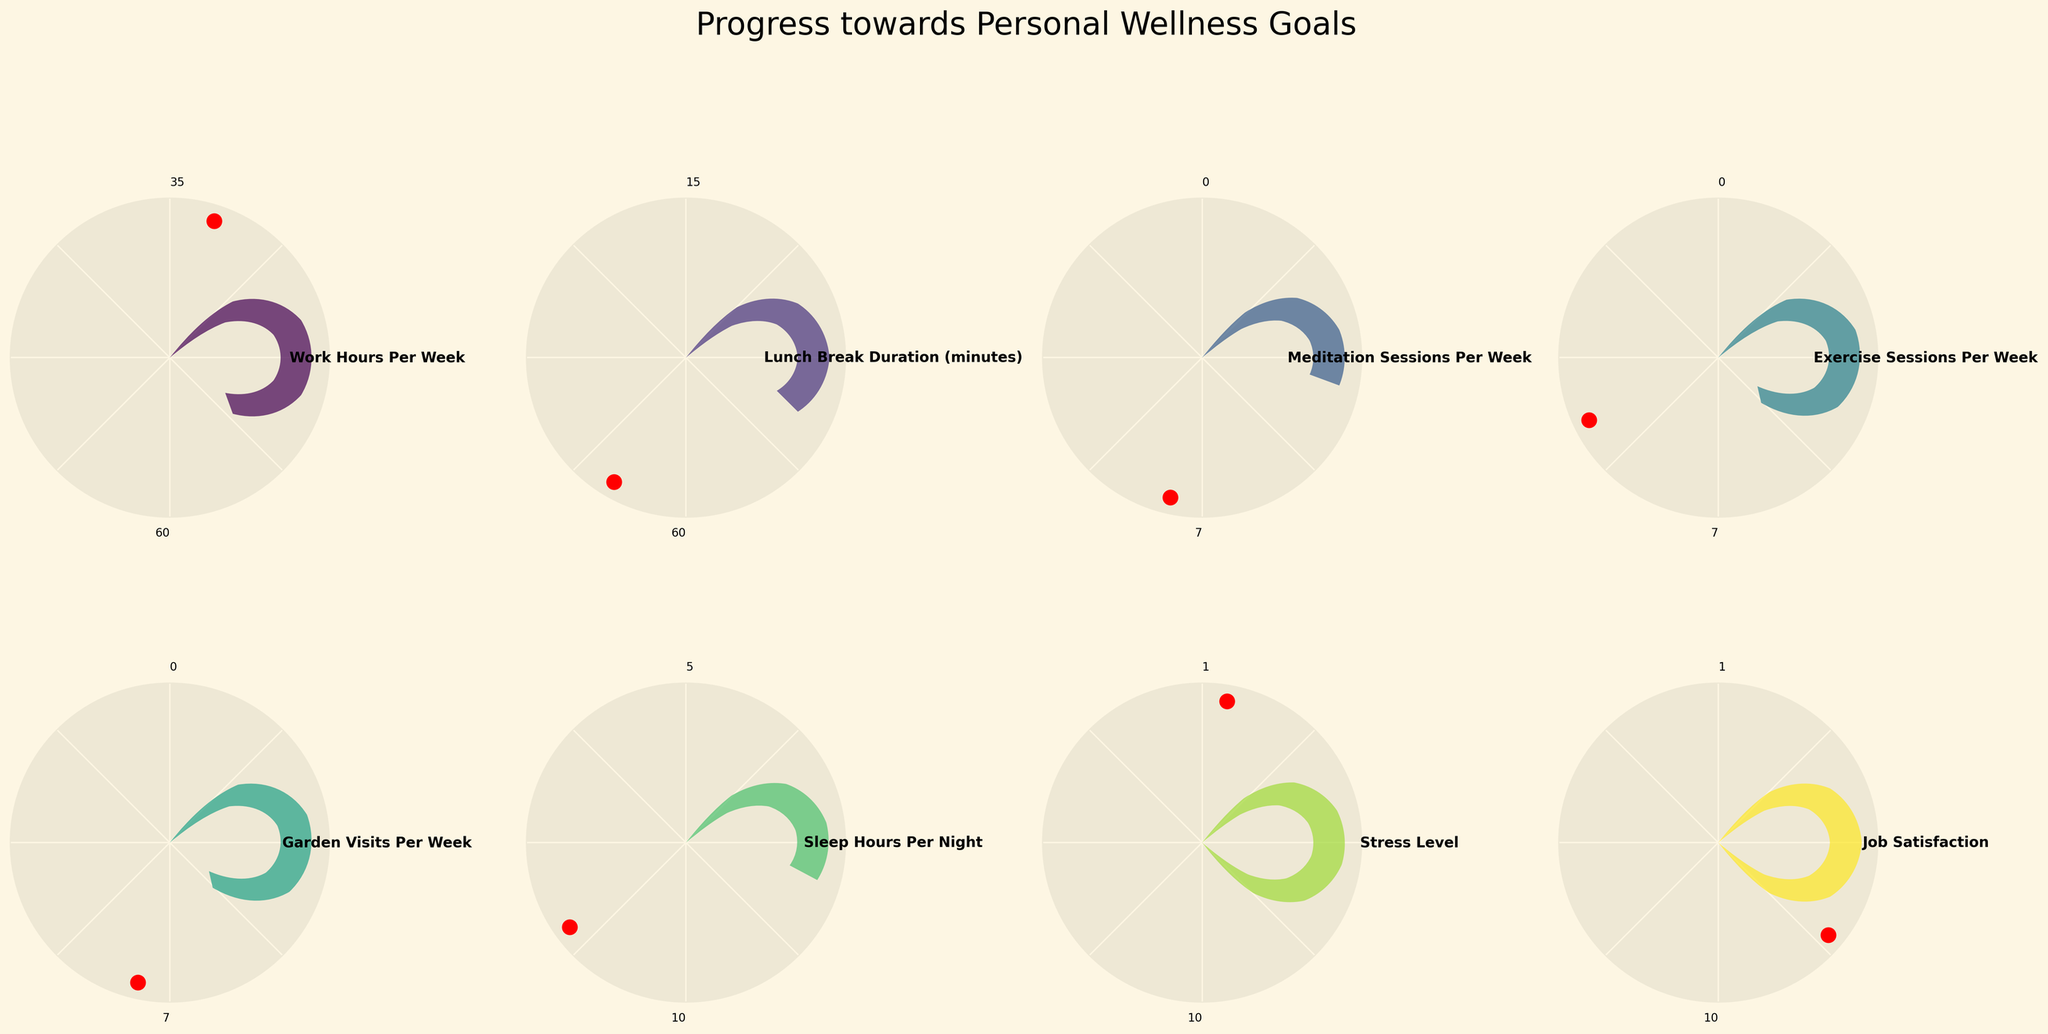What is the title of the figure? The title of the figure is displayed at the top center.
Answer: Progress towards Personal Wellness Goals What is the current value for "Work Hours Per Week"? The current value is labeled near the center of the gauge chart under the title "Work Hours Per Week."
Answer: 45 What is the target value for "Meditation Sessions Per Week"? The target value is labeled near the center of the gauge chart under the title "Meditation Sessions Per Week."
Answer: 5 Which goal has the highest max value? Examine the labels indicating max values near the top edge of each gauge chart; compare the numbers.
Answer: Work Hours Per Week How many goals have a current value below their target value? Compare each current value to its corresponding target value across the gauge charts.
Answer: 6 What is the difference between the current and target value for "Exercise Sessions Per Week"? Subtract the current value from the target value for "Exercise Sessions Per Week." 4 - 3 = 1
Answer: 1 Which goal has the largest gap between its current value and min value? Subtract the min value from the current value for each goal and identify which has the largest result.
Answer: Work Hours Per Week How close is the current value of "Stress Level" to its target value? Subtract the target value from the current value for "Stress Level." 6 - 3 = 3
Answer: 3 What is the color scheme used for the gauge charts? The figure uses a gradient of colors, which is part of a color map. Check the labels and overall color intensity for this information.
Answer: Viridis What is the polar coordinate position (in degrees) of the current value indicator for "Sleep Hours Per Night"? The gauge chart uses the polar coordinate system with degrees marked radially; the position can be found visually.
Answer: 54 degrees 